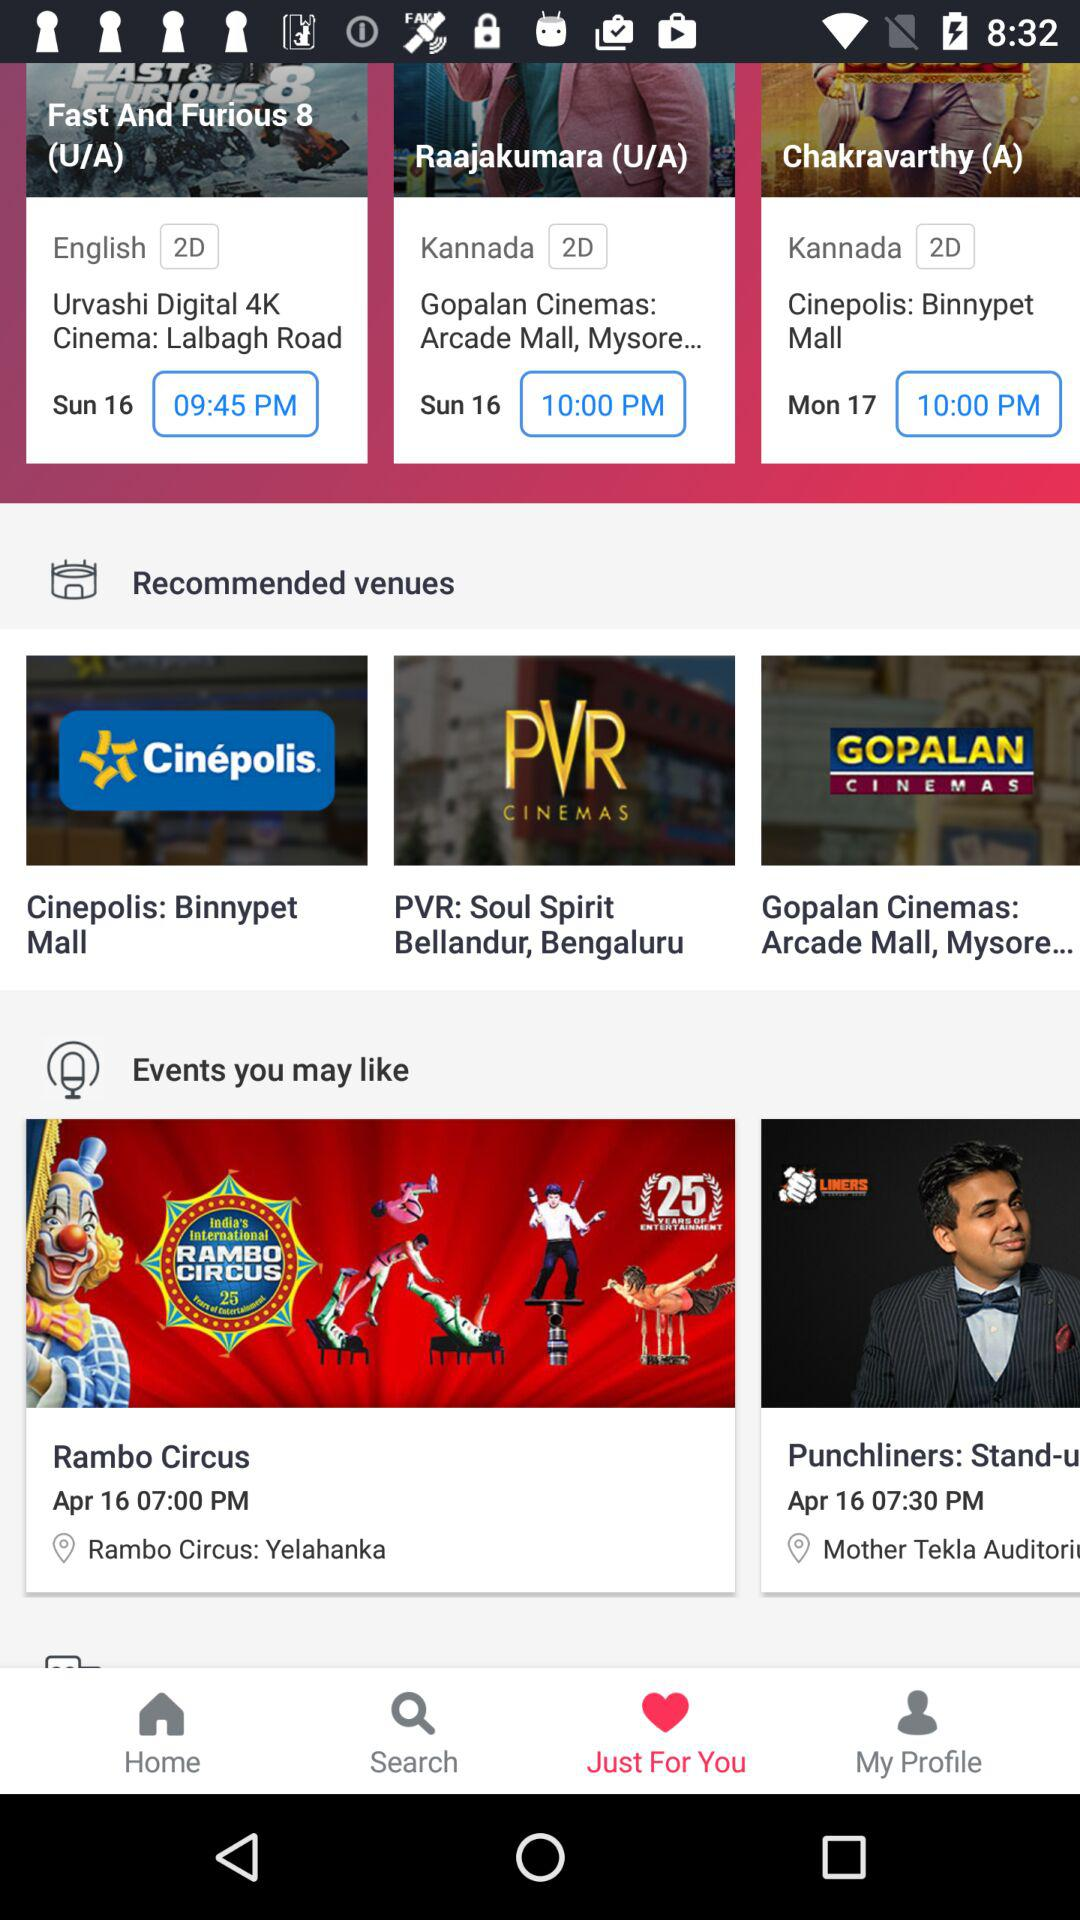How many events are there in the Events you may like section?
Answer the question using a single word or phrase. 2 